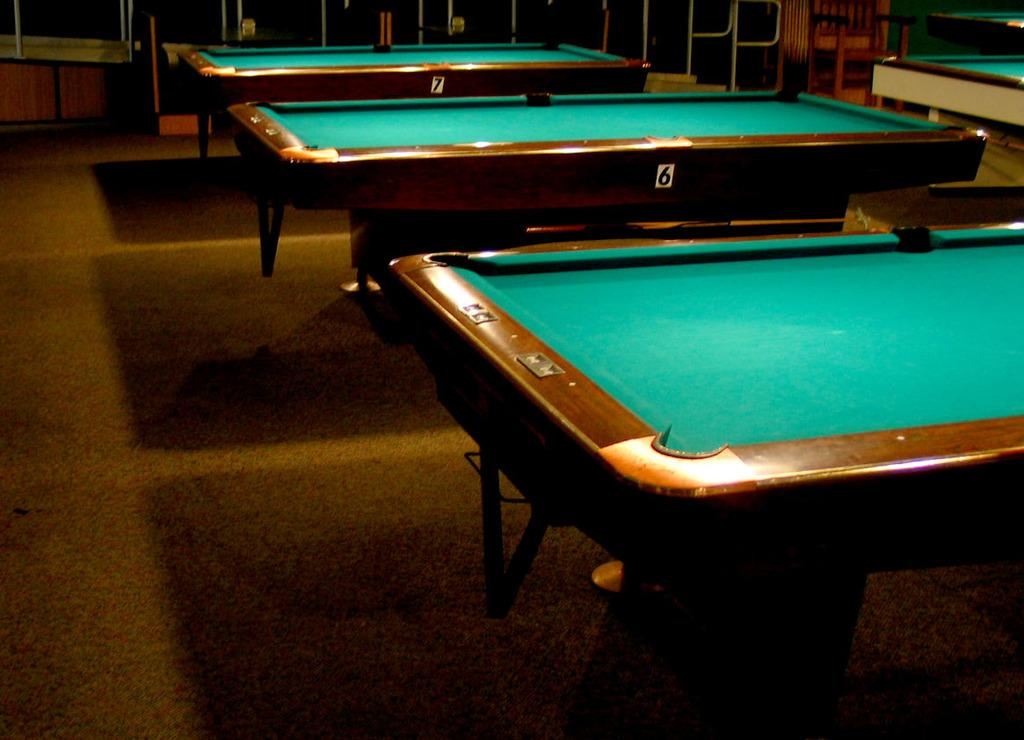How many pool tables are visible in the image? There are three pool tables in the image. What are the names of the pool tables? The pool tables are named 6 and 7. What type of brake is used on the pool tables in the image? There is no brake present on the pool tables in the image, as they are not vehicles or machines that require brakes. 